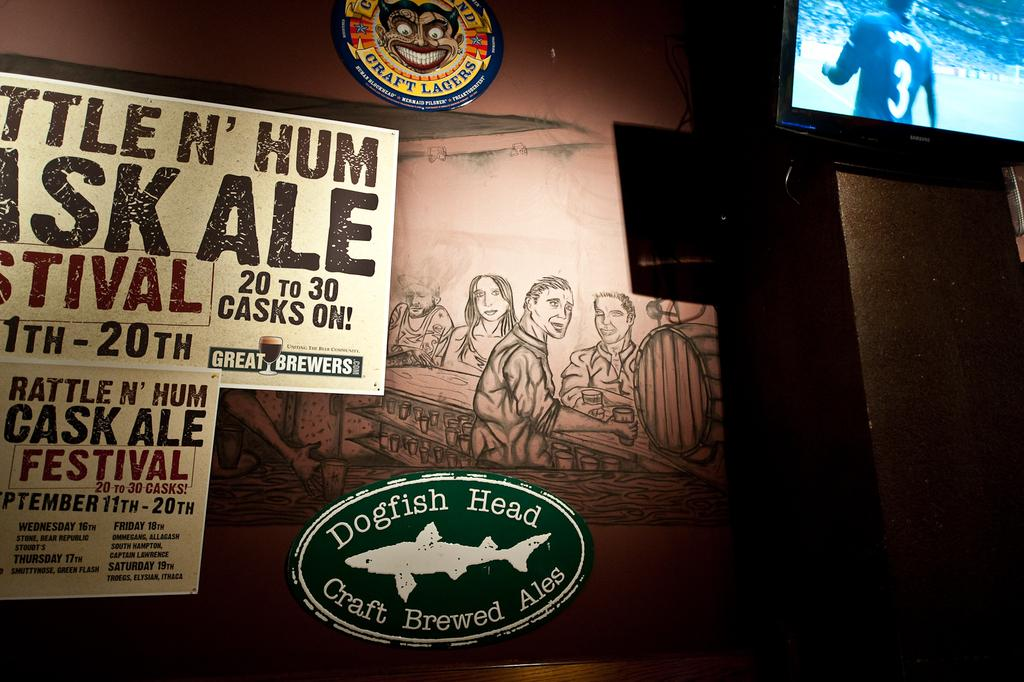What is located on the right top side of the wall in the image? There is a television on the right top side of the wall. What other decorations can be seen on the wall? There are posters and sketches on the wall. How many spoons are hanging from the television in the image? There are no spoons present in the image, and they are not hanging from the television. 